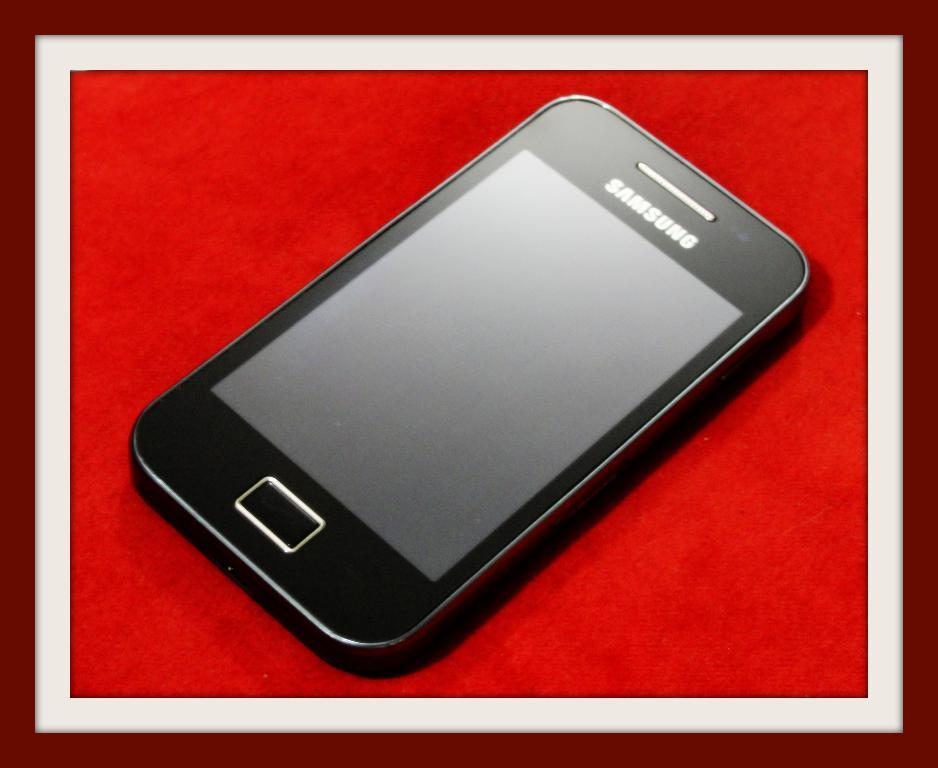<image>
Write a terse but informative summary of the picture. A picture of a black Samsung phone lays on a red surface with a mahogany frame. 